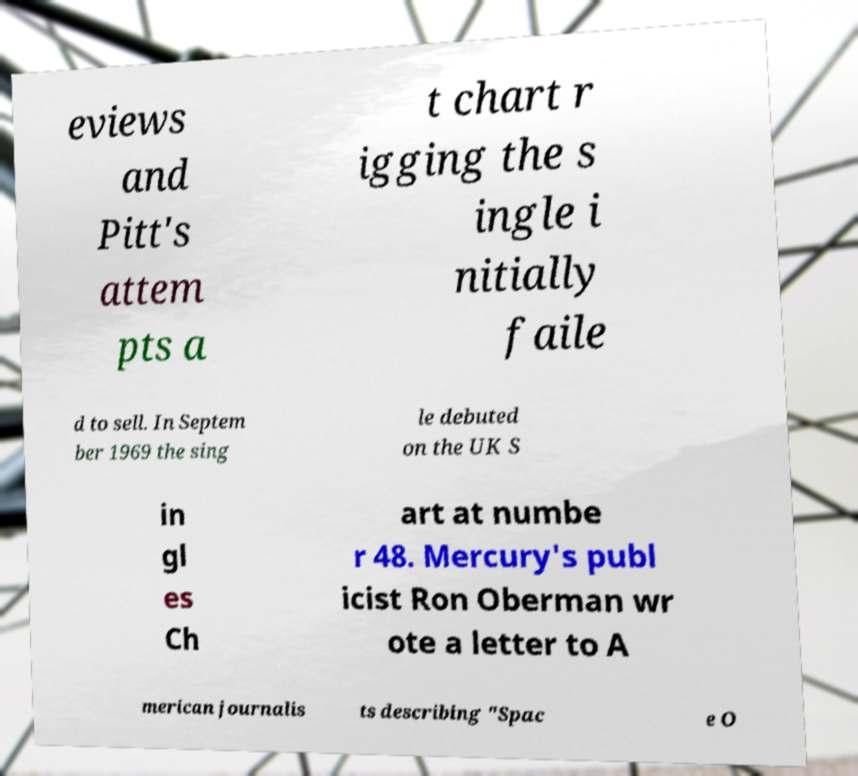Could you extract and type out the text from this image? eviews and Pitt's attem pts a t chart r igging the s ingle i nitially faile d to sell. In Septem ber 1969 the sing le debuted on the UK S in gl es Ch art at numbe r 48. Mercury's publ icist Ron Oberman wr ote a letter to A merican journalis ts describing "Spac e O 